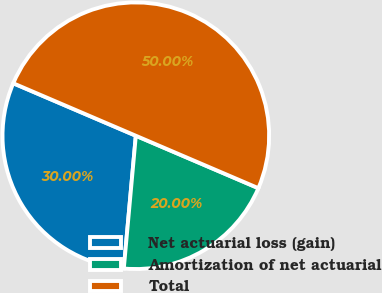Convert chart to OTSL. <chart><loc_0><loc_0><loc_500><loc_500><pie_chart><fcel>Net actuarial loss (gain)<fcel>Amortization of net actuarial<fcel>Total<nl><fcel>30.0%<fcel>20.0%<fcel>50.0%<nl></chart> 